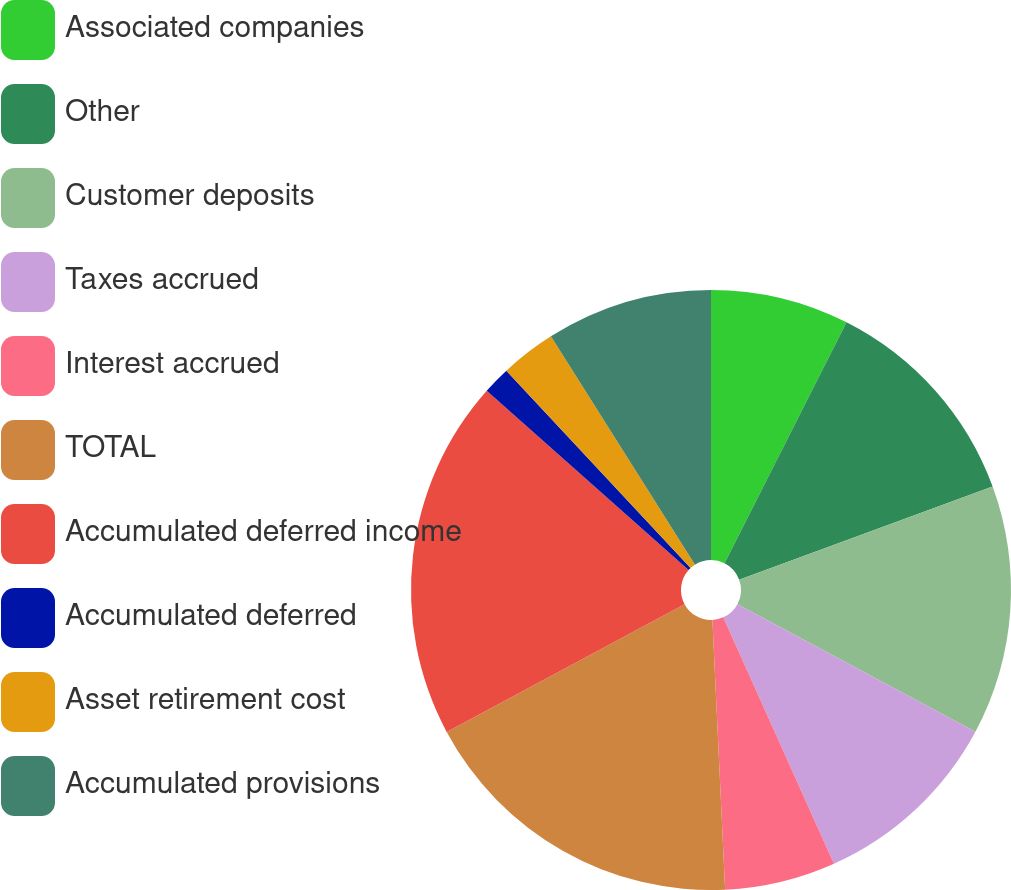Convert chart to OTSL. <chart><loc_0><loc_0><loc_500><loc_500><pie_chart><fcel>Associated companies<fcel>Other<fcel>Customer deposits<fcel>Taxes accrued<fcel>Interest accrued<fcel>TOTAL<fcel>Accumulated deferred income<fcel>Accumulated deferred<fcel>Asset retirement cost<fcel>Accumulated provisions<nl><fcel>7.46%<fcel>11.94%<fcel>13.43%<fcel>10.45%<fcel>5.97%<fcel>17.91%<fcel>19.4%<fcel>1.49%<fcel>2.99%<fcel>8.96%<nl></chart> 